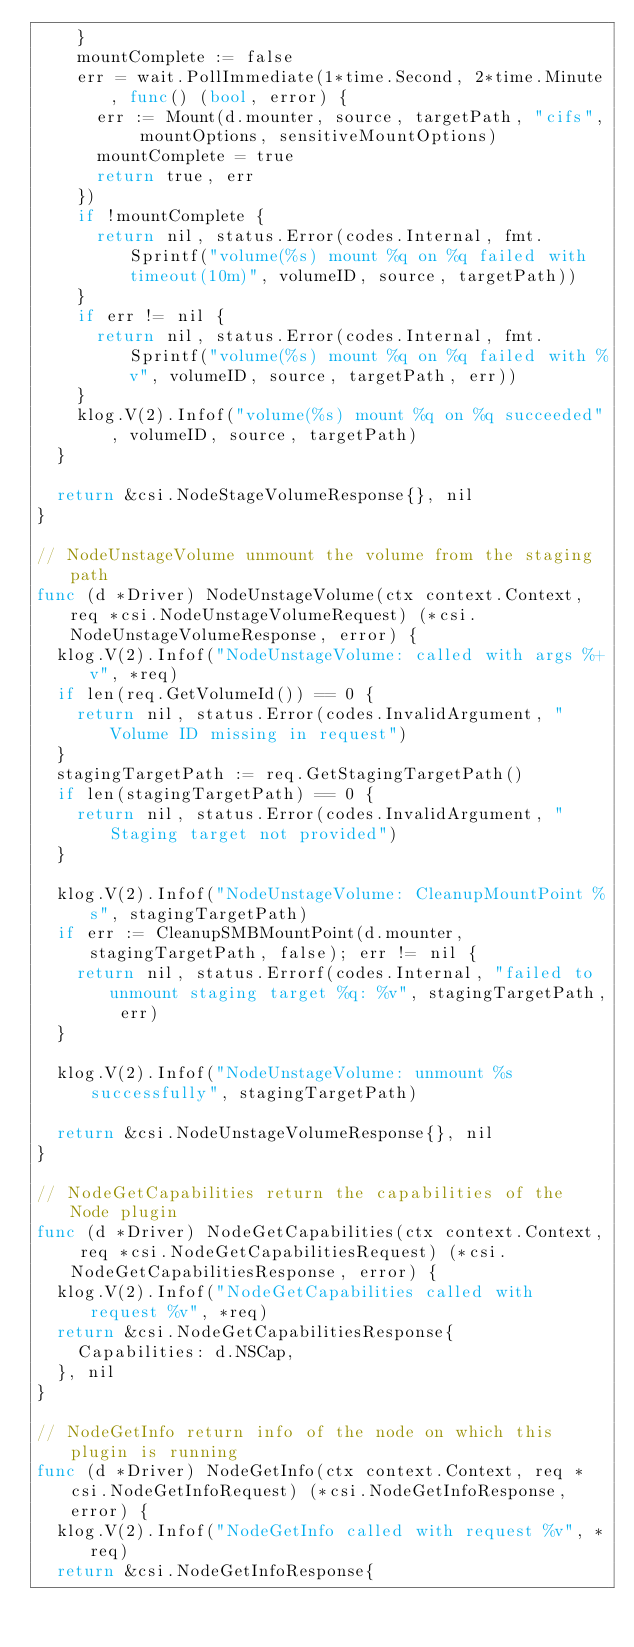Convert code to text. <code><loc_0><loc_0><loc_500><loc_500><_Go_>		}
		mountComplete := false
		err = wait.PollImmediate(1*time.Second, 2*time.Minute, func() (bool, error) {
			err := Mount(d.mounter, source, targetPath, "cifs", mountOptions, sensitiveMountOptions)
			mountComplete = true
			return true, err
		})
		if !mountComplete {
			return nil, status.Error(codes.Internal, fmt.Sprintf("volume(%s) mount %q on %q failed with timeout(10m)", volumeID, source, targetPath))
		}
		if err != nil {
			return nil, status.Error(codes.Internal, fmt.Sprintf("volume(%s) mount %q on %q failed with %v", volumeID, source, targetPath, err))
		}
		klog.V(2).Infof("volume(%s) mount %q on %q succeeded", volumeID, source, targetPath)
	}

	return &csi.NodeStageVolumeResponse{}, nil
}

// NodeUnstageVolume unmount the volume from the staging path
func (d *Driver) NodeUnstageVolume(ctx context.Context, req *csi.NodeUnstageVolumeRequest) (*csi.NodeUnstageVolumeResponse, error) {
	klog.V(2).Infof("NodeUnstageVolume: called with args %+v", *req)
	if len(req.GetVolumeId()) == 0 {
		return nil, status.Error(codes.InvalidArgument, "Volume ID missing in request")
	}
	stagingTargetPath := req.GetStagingTargetPath()
	if len(stagingTargetPath) == 0 {
		return nil, status.Error(codes.InvalidArgument, "Staging target not provided")
	}

	klog.V(2).Infof("NodeUnstageVolume: CleanupMountPoint %s", stagingTargetPath)
	if err := CleanupSMBMountPoint(d.mounter, stagingTargetPath, false); err != nil {
		return nil, status.Errorf(codes.Internal, "failed to unmount staging target %q: %v", stagingTargetPath, err)
	}

	klog.V(2).Infof("NodeUnstageVolume: unmount %s successfully", stagingTargetPath)

	return &csi.NodeUnstageVolumeResponse{}, nil
}

// NodeGetCapabilities return the capabilities of the Node plugin
func (d *Driver) NodeGetCapabilities(ctx context.Context, req *csi.NodeGetCapabilitiesRequest) (*csi.NodeGetCapabilitiesResponse, error) {
	klog.V(2).Infof("NodeGetCapabilities called with request %v", *req)
	return &csi.NodeGetCapabilitiesResponse{
		Capabilities: d.NSCap,
	}, nil
}

// NodeGetInfo return info of the node on which this plugin is running
func (d *Driver) NodeGetInfo(ctx context.Context, req *csi.NodeGetInfoRequest) (*csi.NodeGetInfoResponse, error) {
	klog.V(2).Infof("NodeGetInfo called with request %v", *req)
	return &csi.NodeGetInfoResponse{</code> 